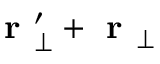Convert formula to latex. <formula><loc_0><loc_0><loc_500><loc_500>r _ { \perp } ^ { \prime } + r _ { \perp }</formula> 